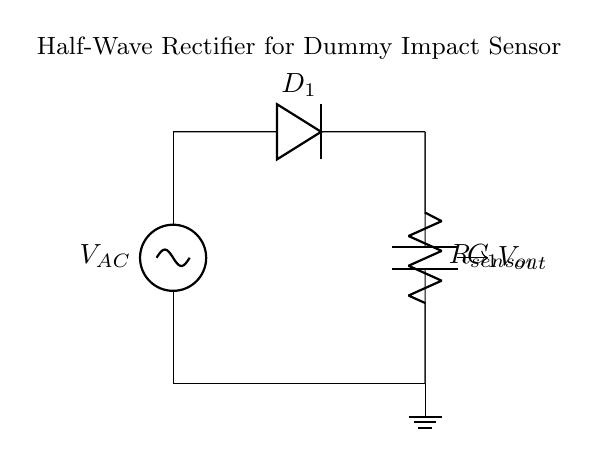What is the type of rectifier shown? The circuit is a half-wave rectifier, as indicated by the single diode and the method of rectification that allows only one half of the AC signal to pass through.
Answer: half-wave rectifier What component limits the current flow in the circuit? The diode labeled D1 is the component that limits the current flow, allowing it to pass only in one direction, which is characteristic of rectifiers.
Answer: diode What is the role of the capacitor in this circuit? The capacitor C1 serves to filter and smooth the rectified output voltage, reducing fluctuations and providing a more stable DC voltage for the sensor.
Answer: smooths output What does R sensor represent in this circuit? R sensor represents the dummy impact sensor that receives the electrical energy converted by the rectifier and is indicative of the load connected to the circuit.
Answer: dummy sensor How many diodes are used in the circuit? There is one diode used in the half-wave rectifier configuration. This diode allows current to flow during one half-cycle of the AC input and blocks it during the other half-cycle.
Answer: one What is the output voltage labeled as in the circuit? The output voltage is labeled as Vout, which indicates the voltage available to the load after rectification.
Answer: Vout At what point does the output voltage drop in this circuit? The output voltage drops at the diode D1 when it is reverse-biased, which occurs during the negative half-cycle of the input AC voltage.
Answer: negative half-cycle 